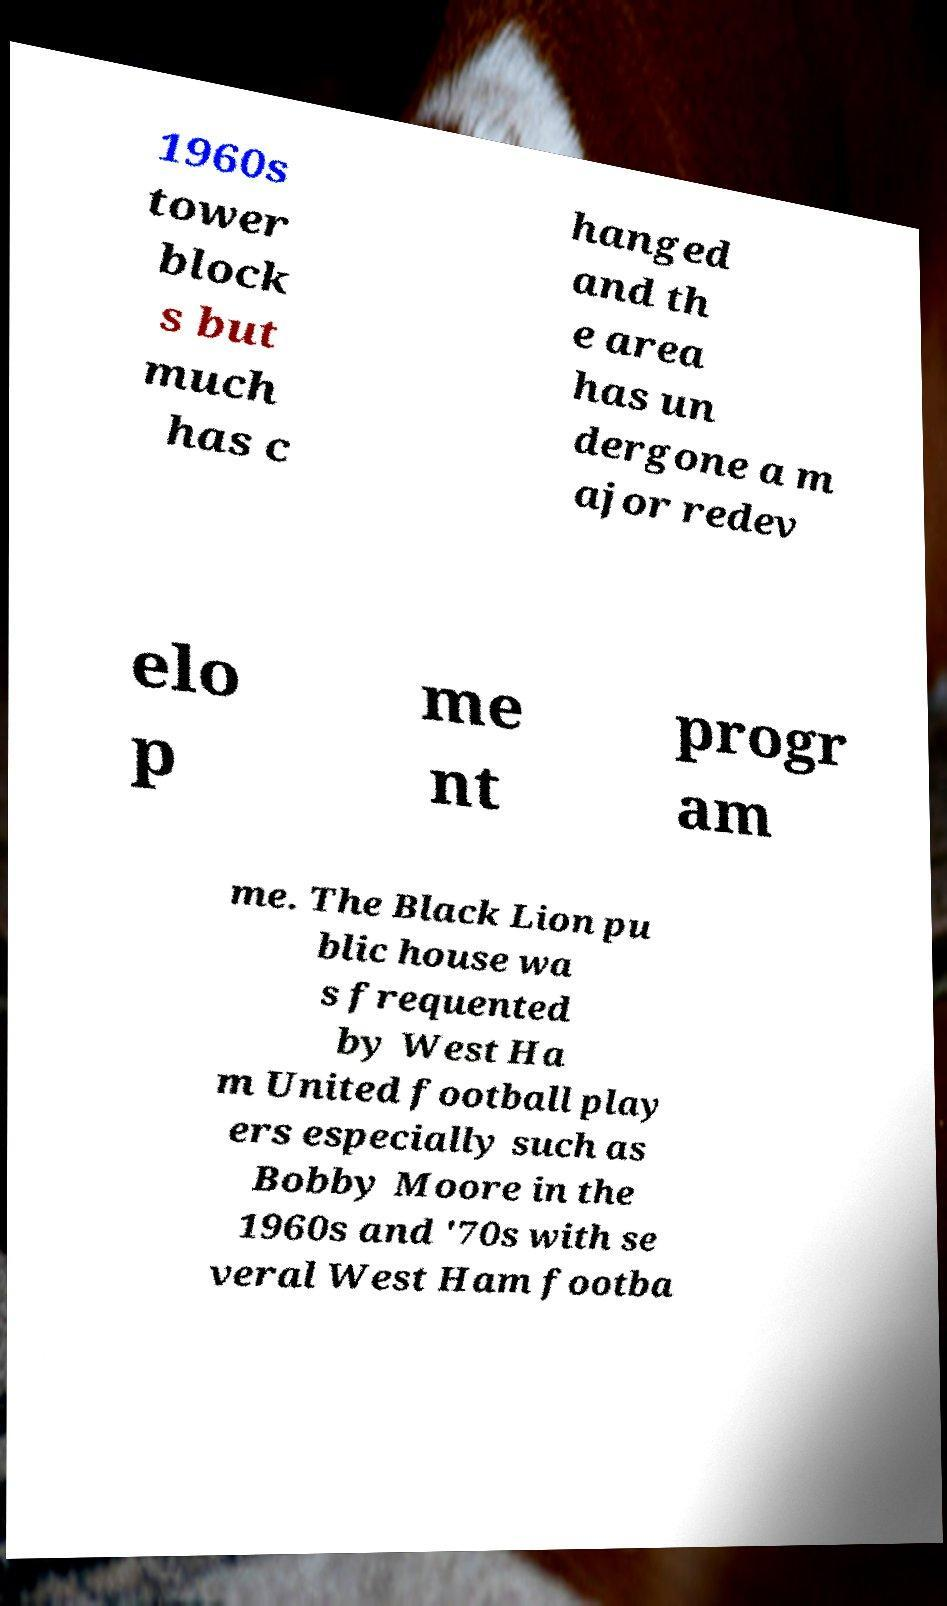Could you extract and type out the text from this image? 1960s tower block s but much has c hanged and th e area has un dergone a m ajor redev elo p me nt progr am me. The Black Lion pu blic house wa s frequented by West Ha m United football play ers especially such as Bobby Moore in the 1960s and '70s with se veral West Ham footba 